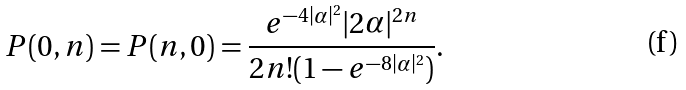<formula> <loc_0><loc_0><loc_500><loc_500>P ( 0 , n ) = P ( n , 0 ) = \frac { e ^ { - 4 | \alpha | ^ { 2 } } | 2 \alpha | ^ { 2 n } } { 2 n ! ( 1 - e ^ { - 8 | \alpha | ^ { 2 } } ) } .</formula> 